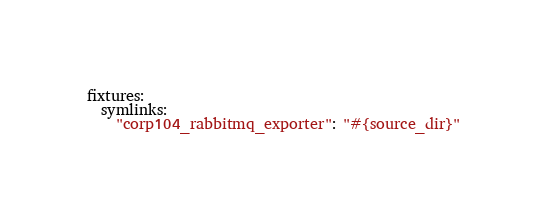Convert code to text. <code><loc_0><loc_0><loc_500><loc_500><_YAML_>fixtures:
  symlinks:
    "corp104_rabbitmq_exporter": "#{source_dir}"</code> 